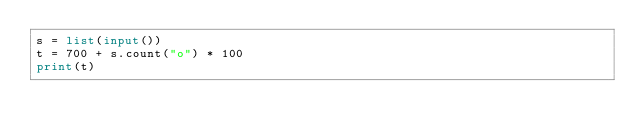Convert code to text. <code><loc_0><loc_0><loc_500><loc_500><_Python_>s = list(input())
t = 700 + s.count("o") * 100
print(t)</code> 